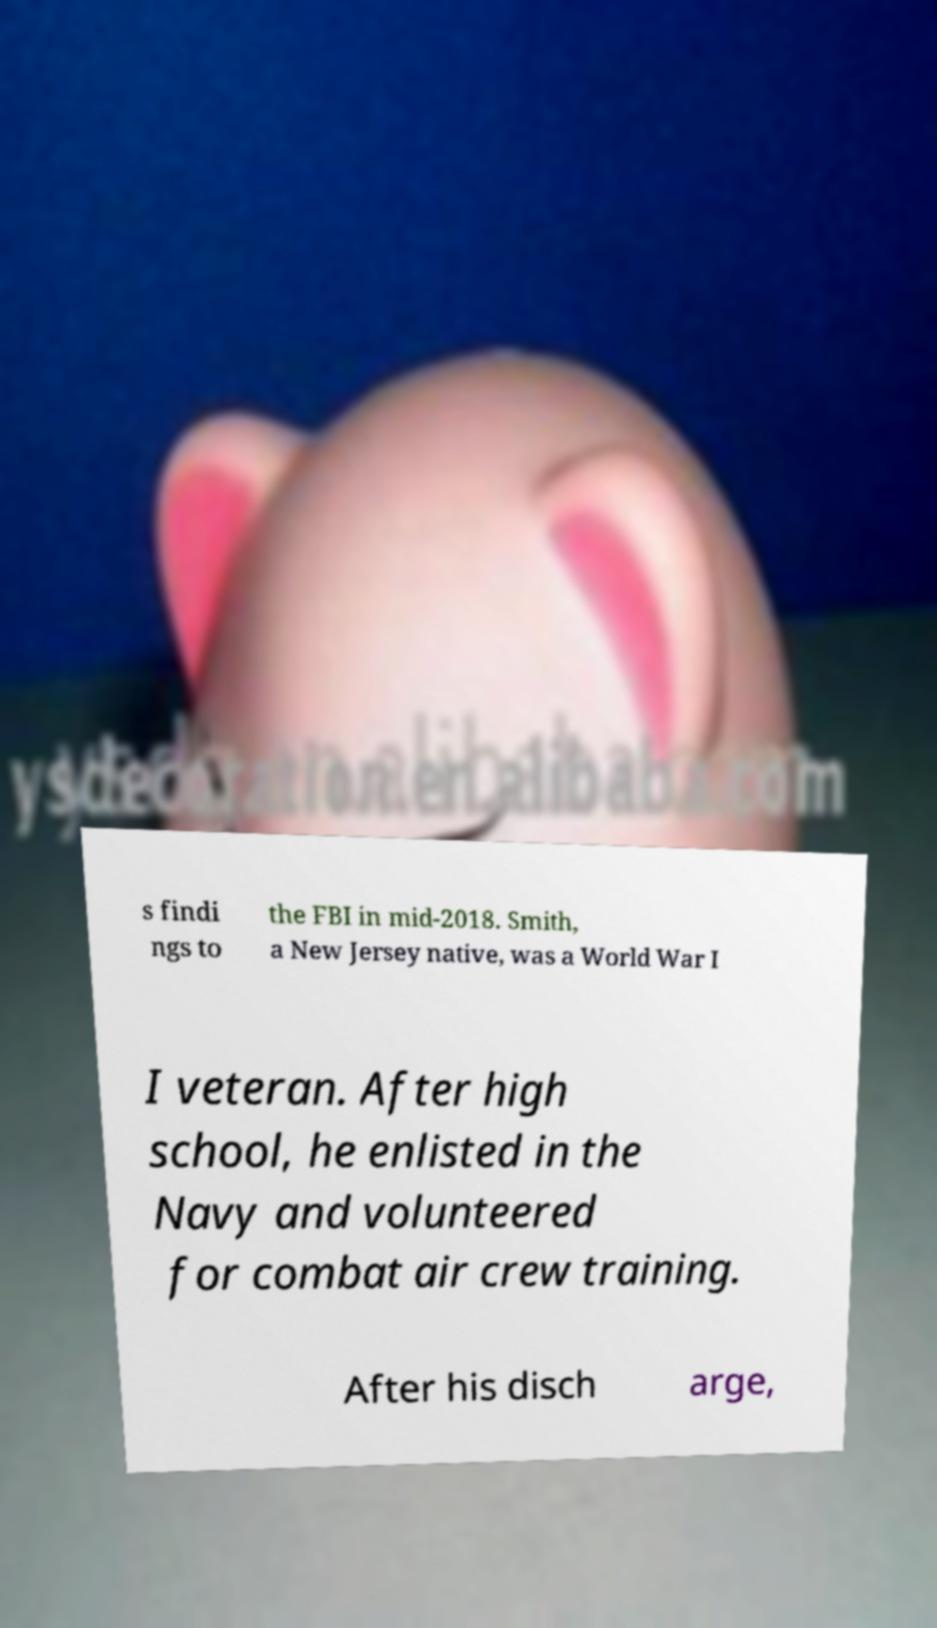What messages or text are displayed in this image? I need them in a readable, typed format. s findi ngs to the FBI in mid-2018. Smith, a New Jersey native, was a World War I I veteran. After high school, he enlisted in the Navy and volunteered for combat air crew training. After his disch arge, 